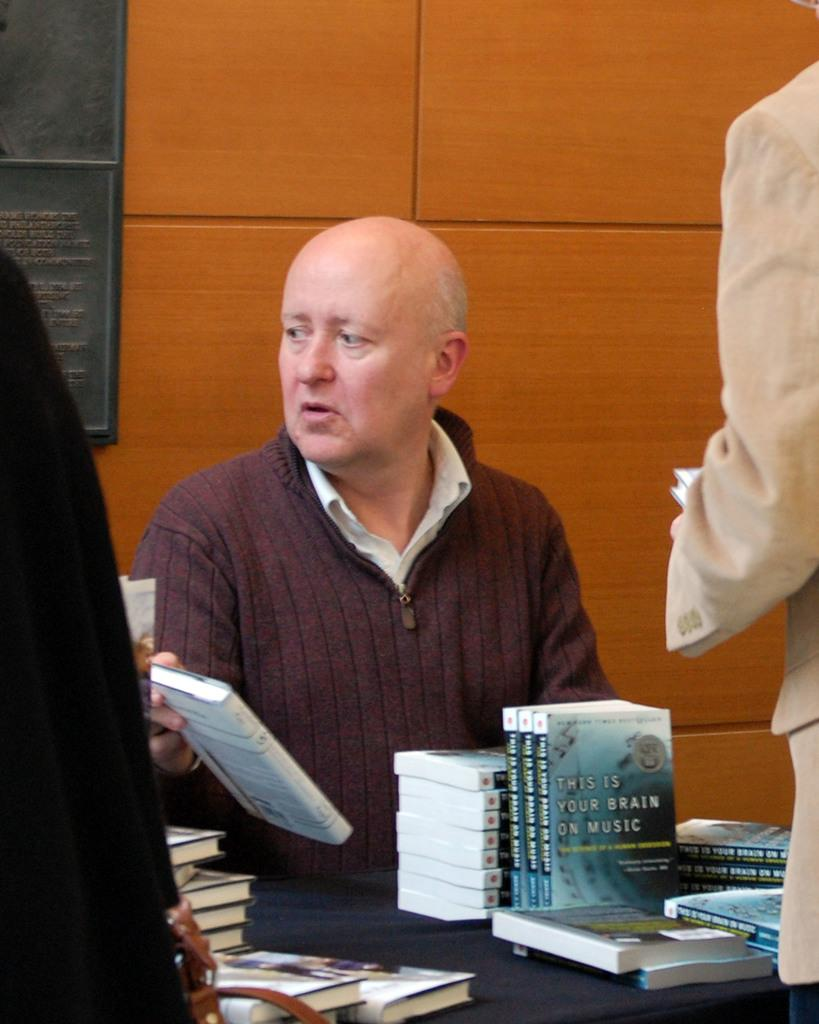<image>
Offer a succinct explanation of the picture presented. A man sits behind a stack of This is your Brain on Music books. 